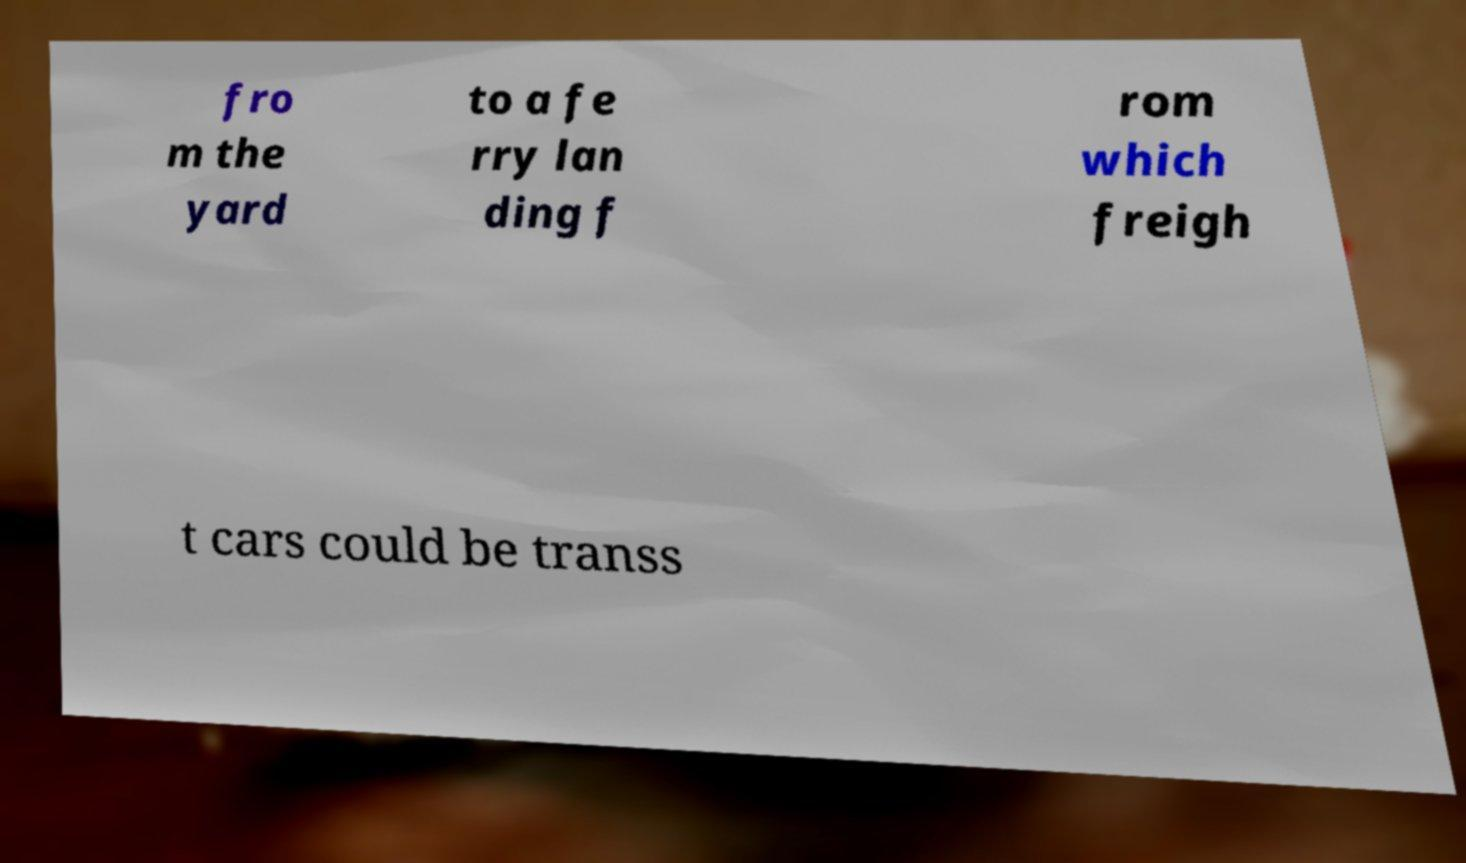Please read and relay the text visible in this image. What does it say? fro m the yard to a fe rry lan ding f rom which freigh t cars could be transs 